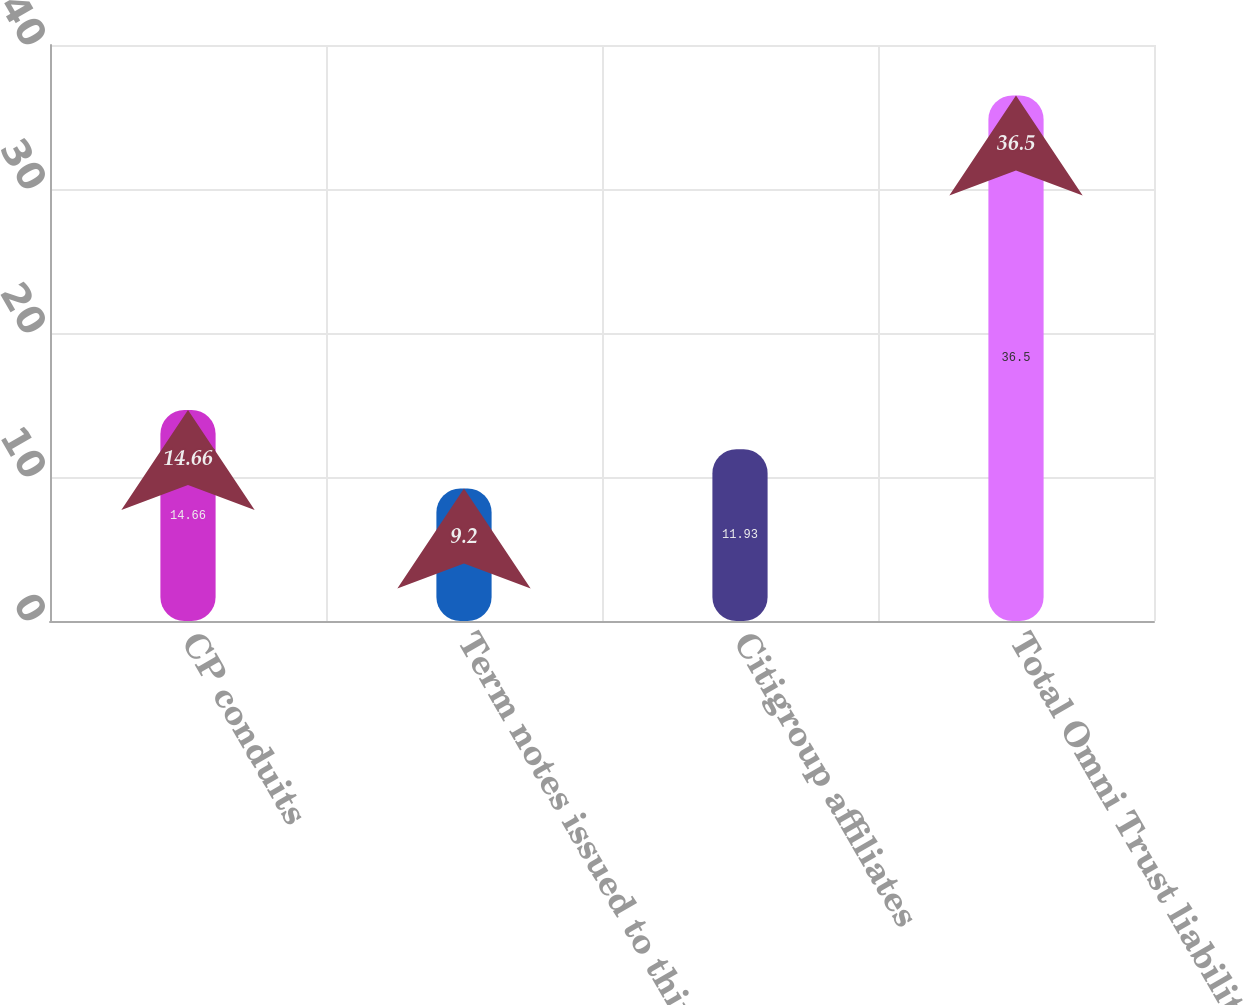Convert chart. <chart><loc_0><loc_0><loc_500><loc_500><bar_chart><fcel>CP conduits<fcel>Term notes issued to third<fcel>Citigroup affiliates<fcel>Total Omni Trust liabilities<nl><fcel>14.66<fcel>9.2<fcel>11.93<fcel>36.5<nl></chart> 